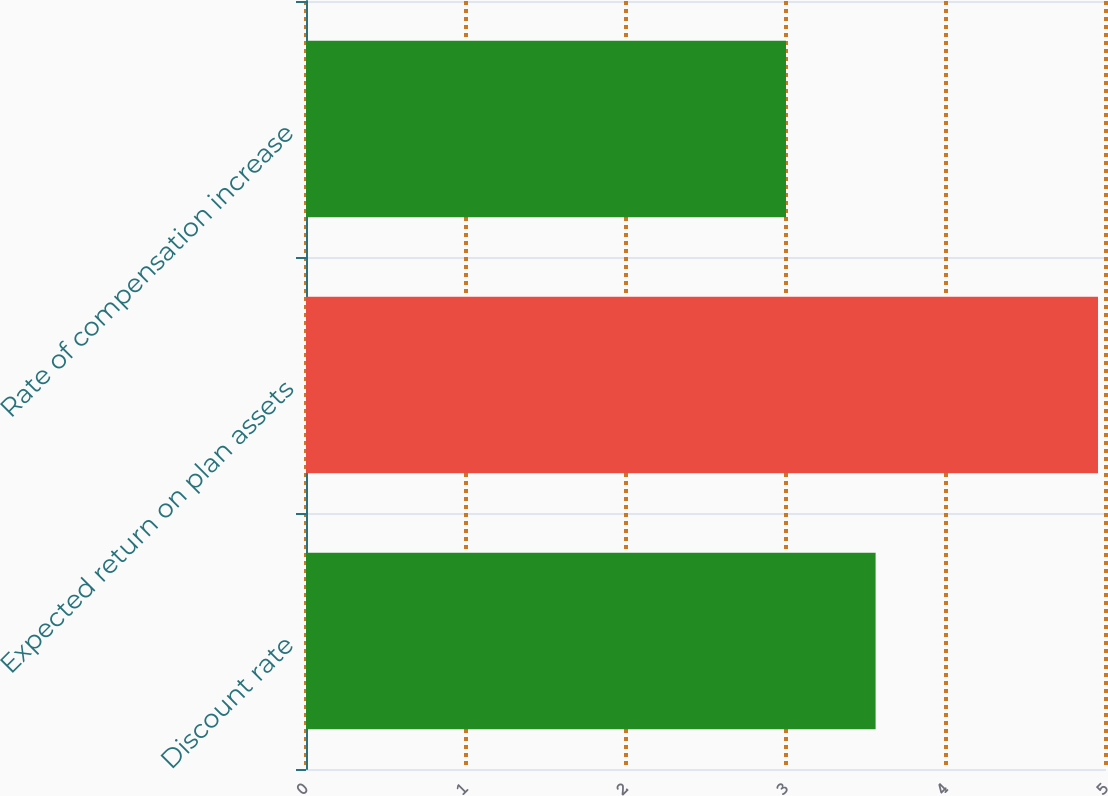Convert chart to OTSL. <chart><loc_0><loc_0><loc_500><loc_500><bar_chart><fcel>Discount rate<fcel>Expected return on plan assets<fcel>Rate of compensation increase<nl><fcel>3.56<fcel>4.95<fcel>3<nl></chart> 